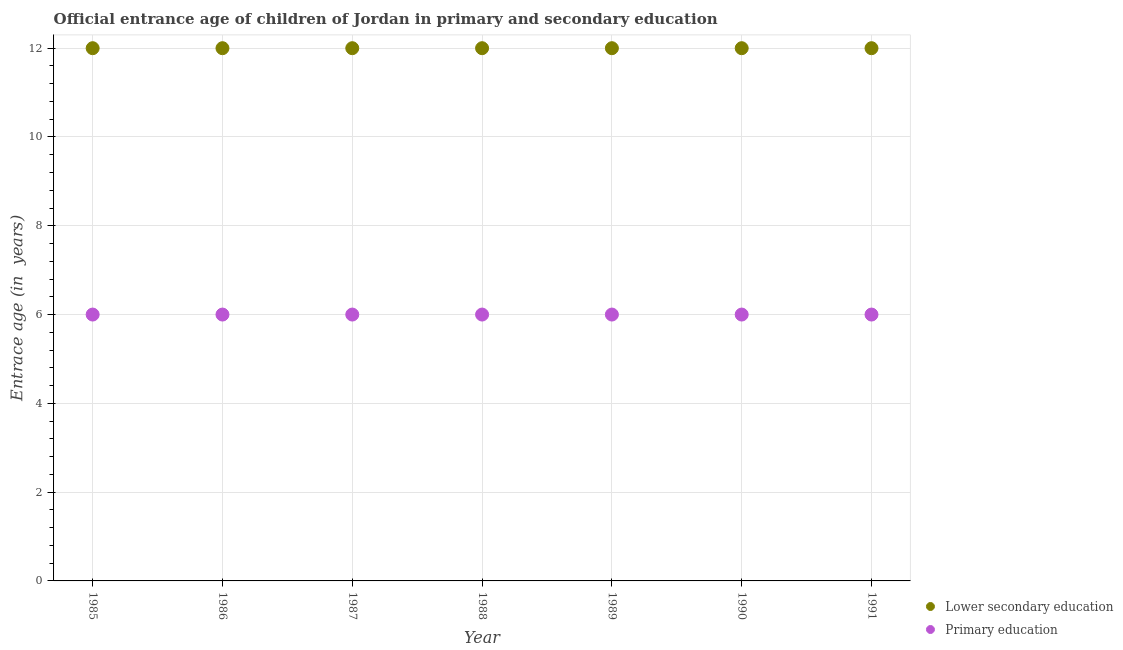What is the entrance age of children in lower secondary education in 1991?
Give a very brief answer. 12. Across all years, what is the minimum entrance age of chiildren in primary education?
Your answer should be compact. 6. What is the total entrance age of children in lower secondary education in the graph?
Offer a very short reply. 84. What is the difference between the entrance age of children in lower secondary education in 1985 and that in 1986?
Make the answer very short. 0. What is the difference between the entrance age of chiildren in primary education in 1985 and the entrance age of children in lower secondary education in 1988?
Your answer should be compact. -6. What is the average entrance age of chiildren in primary education per year?
Your response must be concise. 6. In the year 1988, what is the difference between the entrance age of chiildren in primary education and entrance age of children in lower secondary education?
Provide a succinct answer. -6. In how many years, is the entrance age of children in lower secondary education greater than 2 years?
Offer a terse response. 7. Is the entrance age of children in lower secondary education in 1986 less than that in 1988?
Provide a succinct answer. No. What is the difference between the highest and the lowest entrance age of children in lower secondary education?
Keep it short and to the point. 0. In how many years, is the entrance age of chiildren in primary education greater than the average entrance age of chiildren in primary education taken over all years?
Make the answer very short. 0. Is the sum of the entrance age of children in lower secondary education in 1985 and 1988 greater than the maximum entrance age of chiildren in primary education across all years?
Keep it short and to the point. Yes. Does the entrance age of chiildren in primary education monotonically increase over the years?
Keep it short and to the point. No. Is the entrance age of children in lower secondary education strictly less than the entrance age of chiildren in primary education over the years?
Make the answer very short. No. How many dotlines are there?
Your answer should be compact. 2. How many years are there in the graph?
Your answer should be compact. 7. How many legend labels are there?
Provide a short and direct response. 2. How are the legend labels stacked?
Offer a terse response. Vertical. What is the title of the graph?
Provide a succinct answer. Official entrance age of children of Jordan in primary and secondary education. Does "From Government" appear as one of the legend labels in the graph?
Offer a terse response. No. What is the label or title of the X-axis?
Offer a very short reply. Year. What is the label or title of the Y-axis?
Give a very brief answer. Entrace age (in  years). What is the Entrace age (in  years) of Primary education in 1985?
Ensure brevity in your answer.  6. What is the Entrace age (in  years) of Lower secondary education in 1986?
Make the answer very short. 12. What is the Entrace age (in  years) in Primary education in 1986?
Give a very brief answer. 6. What is the Entrace age (in  years) in Lower secondary education in 1987?
Your answer should be compact. 12. What is the Entrace age (in  years) in Primary education in 1987?
Provide a succinct answer. 6. What is the Entrace age (in  years) of Lower secondary education in 1988?
Your answer should be compact. 12. What is the Entrace age (in  years) of Primary education in 1988?
Your answer should be compact. 6. What is the Entrace age (in  years) in Lower secondary education in 1989?
Your response must be concise. 12. What is the Entrace age (in  years) of Lower secondary education in 1990?
Offer a terse response. 12. What is the Entrace age (in  years) of Lower secondary education in 1991?
Your response must be concise. 12. Across all years, what is the maximum Entrace age (in  years) of Primary education?
Provide a succinct answer. 6. What is the total Entrace age (in  years) in Lower secondary education in the graph?
Provide a short and direct response. 84. What is the difference between the Entrace age (in  years) of Lower secondary education in 1985 and that in 1986?
Offer a terse response. 0. What is the difference between the Entrace age (in  years) in Lower secondary education in 1985 and that in 1987?
Offer a terse response. 0. What is the difference between the Entrace age (in  years) of Primary education in 1985 and that in 1987?
Give a very brief answer. 0. What is the difference between the Entrace age (in  years) in Primary education in 1985 and that in 1988?
Offer a terse response. 0. What is the difference between the Entrace age (in  years) of Lower secondary education in 1985 and that in 1989?
Your response must be concise. 0. What is the difference between the Entrace age (in  years) of Lower secondary education in 1985 and that in 1990?
Offer a terse response. 0. What is the difference between the Entrace age (in  years) of Primary education in 1985 and that in 1991?
Your answer should be very brief. 0. What is the difference between the Entrace age (in  years) of Primary education in 1986 and that in 1988?
Give a very brief answer. 0. What is the difference between the Entrace age (in  years) in Lower secondary education in 1986 and that in 1990?
Your response must be concise. 0. What is the difference between the Entrace age (in  years) of Primary education in 1986 and that in 1991?
Provide a succinct answer. 0. What is the difference between the Entrace age (in  years) of Lower secondary education in 1987 and that in 1988?
Your answer should be compact. 0. What is the difference between the Entrace age (in  years) in Primary education in 1987 and that in 1988?
Make the answer very short. 0. What is the difference between the Entrace age (in  years) of Lower secondary education in 1987 and that in 1989?
Your response must be concise. 0. What is the difference between the Entrace age (in  years) of Primary education in 1987 and that in 1990?
Provide a short and direct response. 0. What is the difference between the Entrace age (in  years) in Lower secondary education in 1988 and that in 1989?
Provide a short and direct response. 0. What is the difference between the Entrace age (in  years) of Primary education in 1988 and that in 1990?
Your answer should be compact. 0. What is the difference between the Entrace age (in  years) in Lower secondary education in 1988 and that in 1991?
Your answer should be compact. 0. What is the difference between the Entrace age (in  years) in Lower secondary education in 1989 and that in 1990?
Offer a very short reply. 0. What is the difference between the Entrace age (in  years) in Primary education in 1989 and that in 1990?
Your response must be concise. 0. What is the difference between the Entrace age (in  years) of Primary education in 1989 and that in 1991?
Give a very brief answer. 0. What is the difference between the Entrace age (in  years) of Primary education in 1990 and that in 1991?
Your answer should be compact. 0. What is the difference between the Entrace age (in  years) in Lower secondary education in 1985 and the Entrace age (in  years) in Primary education in 1986?
Keep it short and to the point. 6. What is the difference between the Entrace age (in  years) in Lower secondary education in 1985 and the Entrace age (in  years) in Primary education in 1987?
Your response must be concise. 6. What is the difference between the Entrace age (in  years) in Lower secondary education in 1986 and the Entrace age (in  years) in Primary education in 1987?
Offer a very short reply. 6. What is the difference between the Entrace age (in  years) in Lower secondary education in 1986 and the Entrace age (in  years) in Primary education in 1988?
Provide a succinct answer. 6. What is the difference between the Entrace age (in  years) in Lower secondary education in 1986 and the Entrace age (in  years) in Primary education in 1989?
Offer a terse response. 6. What is the difference between the Entrace age (in  years) in Lower secondary education in 1986 and the Entrace age (in  years) in Primary education in 1990?
Your answer should be very brief. 6. What is the difference between the Entrace age (in  years) in Lower secondary education in 1986 and the Entrace age (in  years) in Primary education in 1991?
Your answer should be very brief. 6. What is the difference between the Entrace age (in  years) of Lower secondary education in 1987 and the Entrace age (in  years) of Primary education in 1988?
Offer a terse response. 6. What is the difference between the Entrace age (in  years) in Lower secondary education in 1987 and the Entrace age (in  years) in Primary education in 1989?
Keep it short and to the point. 6. What is the difference between the Entrace age (in  years) of Lower secondary education in 1988 and the Entrace age (in  years) of Primary education in 1991?
Provide a short and direct response. 6. What is the difference between the Entrace age (in  years) of Lower secondary education in 1989 and the Entrace age (in  years) of Primary education in 1990?
Ensure brevity in your answer.  6. What is the difference between the Entrace age (in  years) of Lower secondary education in 1989 and the Entrace age (in  years) of Primary education in 1991?
Offer a terse response. 6. What is the difference between the Entrace age (in  years) of Lower secondary education in 1990 and the Entrace age (in  years) of Primary education in 1991?
Provide a short and direct response. 6. What is the average Entrace age (in  years) in Lower secondary education per year?
Make the answer very short. 12. In the year 1985, what is the difference between the Entrace age (in  years) of Lower secondary education and Entrace age (in  years) of Primary education?
Ensure brevity in your answer.  6. In the year 1988, what is the difference between the Entrace age (in  years) in Lower secondary education and Entrace age (in  years) in Primary education?
Keep it short and to the point. 6. In the year 1991, what is the difference between the Entrace age (in  years) of Lower secondary education and Entrace age (in  years) of Primary education?
Offer a terse response. 6. What is the ratio of the Entrace age (in  years) in Lower secondary education in 1985 to that in 1986?
Offer a terse response. 1. What is the ratio of the Entrace age (in  years) in Lower secondary education in 1985 to that in 1987?
Make the answer very short. 1. What is the ratio of the Entrace age (in  years) in Lower secondary education in 1985 to that in 1988?
Your answer should be compact. 1. What is the ratio of the Entrace age (in  years) of Lower secondary education in 1985 to that in 1989?
Your response must be concise. 1. What is the ratio of the Entrace age (in  years) in Lower secondary education in 1985 to that in 1990?
Your response must be concise. 1. What is the ratio of the Entrace age (in  years) of Primary education in 1985 to that in 1990?
Your answer should be compact. 1. What is the ratio of the Entrace age (in  years) in Lower secondary education in 1986 to that in 1990?
Provide a short and direct response. 1. What is the ratio of the Entrace age (in  years) in Primary education in 1986 to that in 1990?
Make the answer very short. 1. What is the ratio of the Entrace age (in  years) in Lower secondary education in 1987 to that in 1989?
Provide a short and direct response. 1. What is the ratio of the Entrace age (in  years) in Primary education in 1987 to that in 1990?
Provide a succinct answer. 1. What is the ratio of the Entrace age (in  years) of Lower secondary education in 1987 to that in 1991?
Ensure brevity in your answer.  1. What is the ratio of the Entrace age (in  years) of Lower secondary education in 1988 to that in 1990?
Provide a short and direct response. 1. What is the ratio of the Entrace age (in  years) in Primary education in 1988 to that in 1990?
Give a very brief answer. 1. What is the ratio of the Entrace age (in  years) of Primary education in 1989 to that in 1990?
Your answer should be very brief. 1. What is the ratio of the Entrace age (in  years) in Primary education in 1989 to that in 1991?
Provide a succinct answer. 1. What is the difference between the highest and the second highest Entrace age (in  years) of Lower secondary education?
Make the answer very short. 0. 